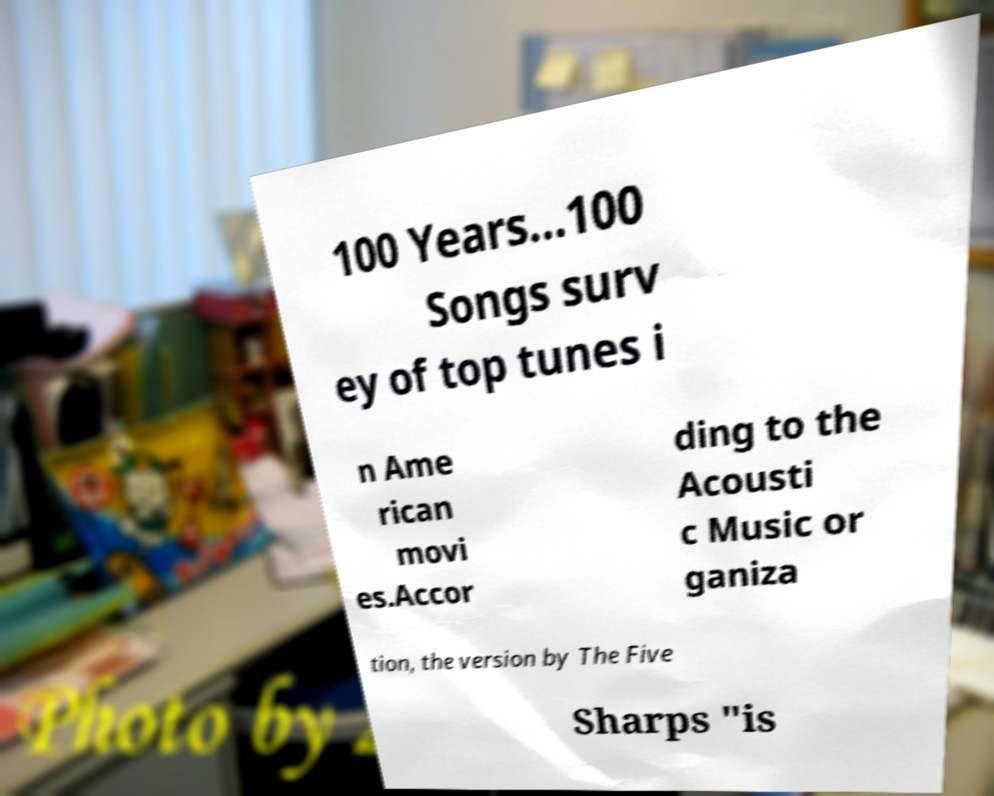There's text embedded in this image that I need extracted. Can you transcribe it verbatim? 100 Years...100 Songs surv ey of top tunes i n Ame rican movi es.Accor ding to the Acousti c Music or ganiza tion, the version by The Five Sharps "is 